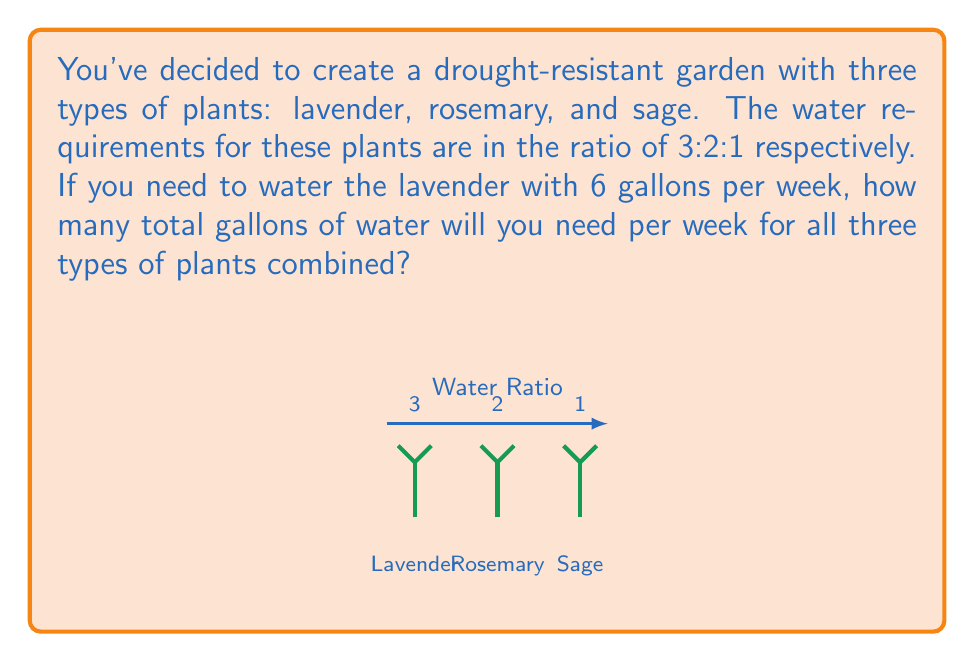Show me your answer to this math problem. Let's solve this step-by-step:

1) We're given that the water requirements ratio for lavender : rosemary : sage is 3:2:1.

2) We know that lavender needs 6 gallons per week. Let's use this to find out what 1 unit in our ratio represents:

   $$ \frac{6 \text{ gallons}}{3 \text{ units}} = 2 \text{ gallons per unit} $$

3) Now we can calculate the water needs for each plant:

   Lavender: $3 \times 2 = 6$ gallons (which we already knew)
   Rosemary: $2 \times 2 = 4$ gallons
   Sage: $1 \times 2 = 2$ gallons

4) To find the total water needed, we sum these amounts:

   $$ 6 + 4 + 2 = 12 \text{ gallons} $$

Therefore, you will need a total of 12 gallons of water per week for all three types of plants combined.
Answer: 12 gallons 